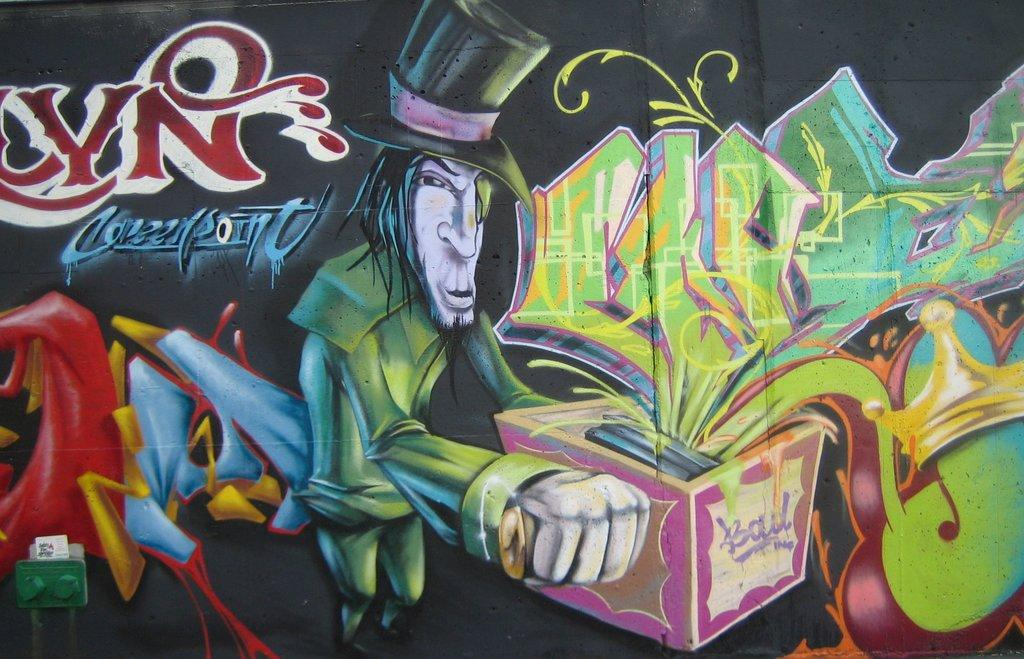What is depicted in the painting in the image? There is a painting of a cartoon man in the image. What is the cartoon man wearing? The cartoon man is wearing a green dress and a black hat. What is the cartoon man holding in the painting? The cartoon man is holding a box. What is happening with the contents of the box? Gifts are coming out of the box. Can you tell me how many houses are visible in the painting? There are no houses depicted in the painting; it features a cartoon man wearing a green dress, a black hat, and holding a box with gifts coming out of it. Is there a frog sitting on the cartoon man's shoulder in the painting? There is no frog present in the painting; it only features the cartoon man and the box with gifts. 